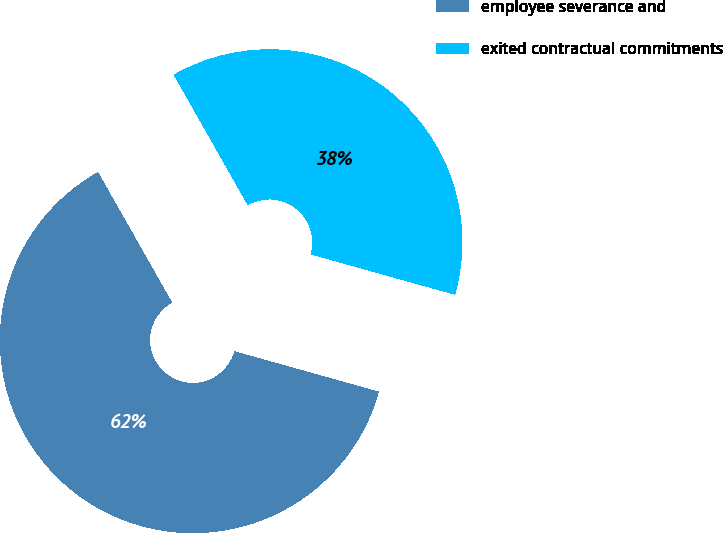<chart> <loc_0><loc_0><loc_500><loc_500><pie_chart><fcel>employee severance and<fcel>exited contractual commitments<nl><fcel>62.44%<fcel>37.56%<nl></chart> 